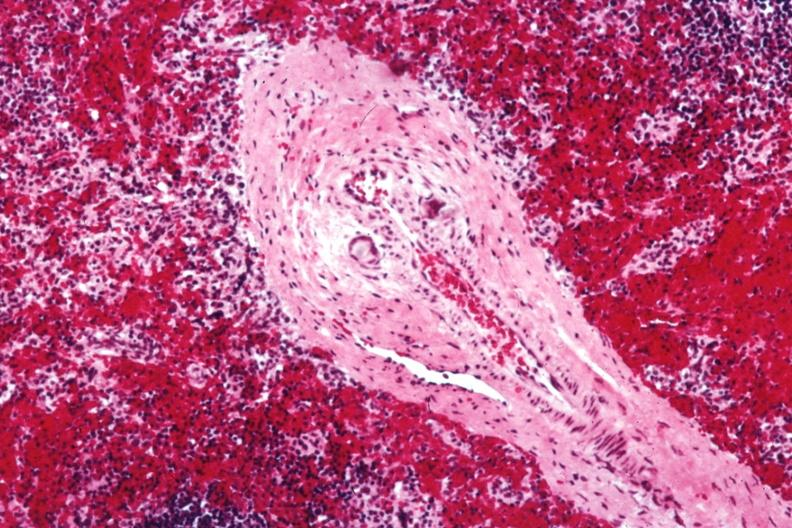what is present?
Answer the question using a single word or phrase. Hematologic 